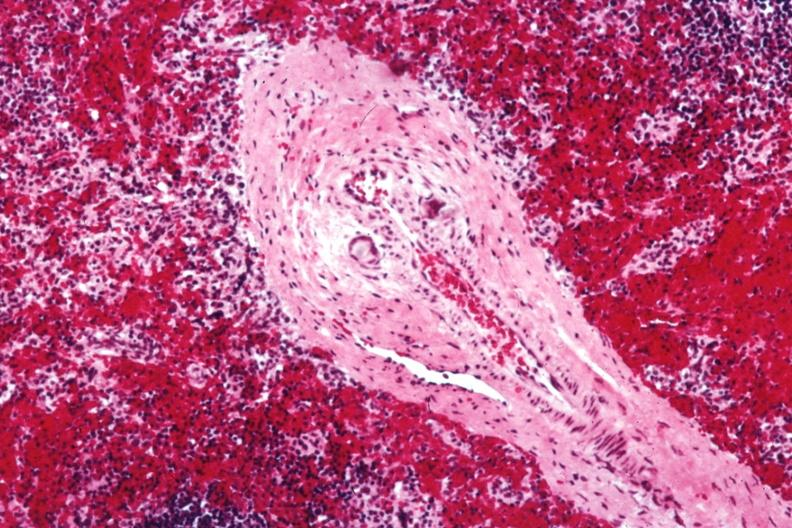what is present?
Answer the question using a single word or phrase. Hematologic 